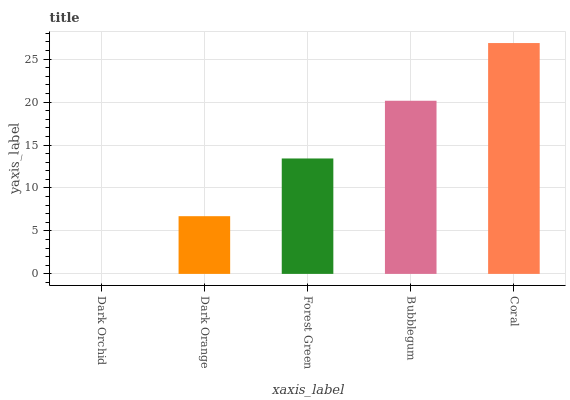Is Dark Orange the minimum?
Answer yes or no. No. Is Dark Orange the maximum?
Answer yes or no. No. Is Dark Orange greater than Dark Orchid?
Answer yes or no. Yes. Is Dark Orchid less than Dark Orange?
Answer yes or no. Yes. Is Dark Orchid greater than Dark Orange?
Answer yes or no. No. Is Dark Orange less than Dark Orchid?
Answer yes or no. No. Is Forest Green the high median?
Answer yes or no. Yes. Is Forest Green the low median?
Answer yes or no. Yes. Is Dark Orchid the high median?
Answer yes or no. No. Is Dark Orange the low median?
Answer yes or no. No. 